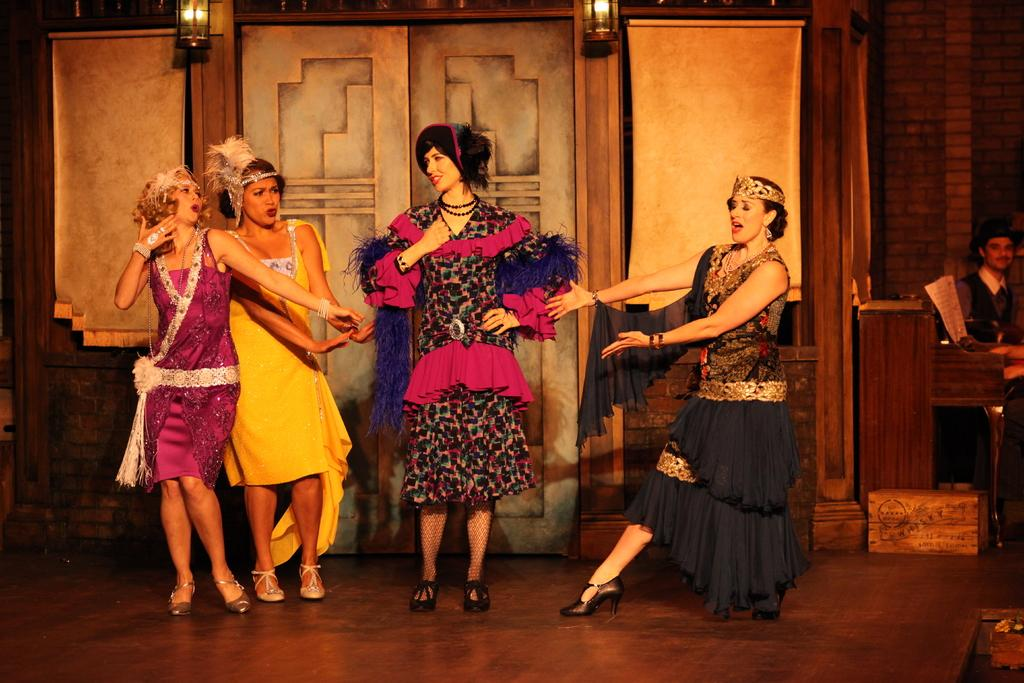What is the main subject of the image on the left side? There is a beautiful woman dancing and singing on the left side of the image. What is the woman wearing? The woman is wearing a dress and a crown. What can be seen in the middle of the image? There are other women dancing in the middle of the image. What is visible behind the women? There are lights visible behind the women. What type of lip can be seen on the woman in the image? There is no lip visible on the woman in the image; she is wearing a crown, not a lip accessory. 